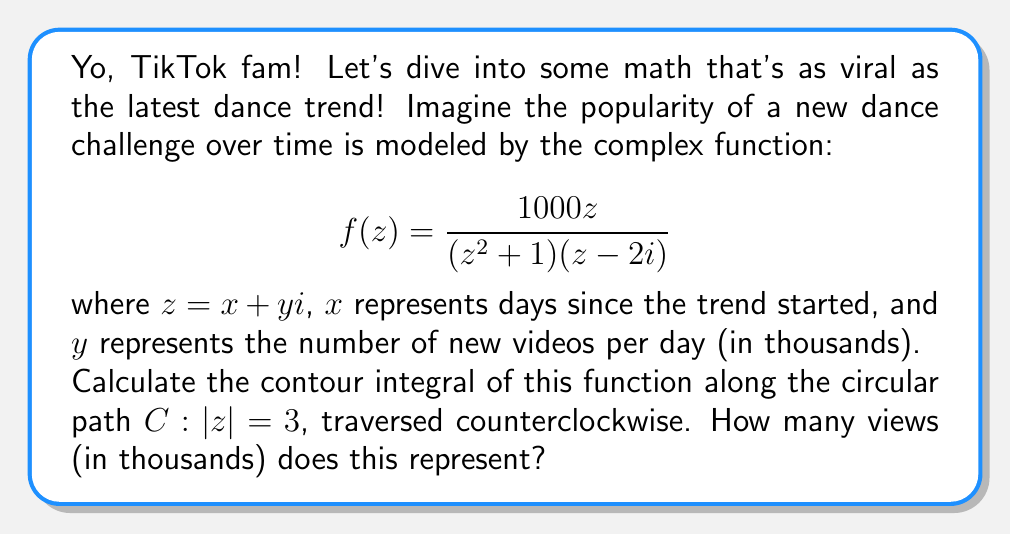Help me with this question. Alright, let's break this down step by step, just like learning a new TikTok dance!

1) First, we need to identify the singularities of the function inside the contour. The poles are:
   - $z = i$ and $z = -i$ from $(z^2 + 1)$
   - $z = 2i$ from $(z - 2i)$

   Only $z = i$ and $z = -i$ are inside our contour $|z| = 3$.

2) Now, we can use the Residue Theorem:

   $$\oint_C f(z) dz = 2\pi i \sum \text{Res}(f, a_k)$$

   where $a_k$ are the poles inside the contour.

3) Let's calculate the residues:

   For $z = i$:
   $$\text{Res}(f, i) = \lim_{z \to i} (z-i)f(z) = \lim_{z \to i} \frac{1000z(z-i)}{(z^2+1)(z-2i)} = \frac{1000i}{2(3i)} = \frac{500}{3}$$

   For $z = -i$:
   $$\text{Res}(f, -i) = \lim_{z \to -i} (z+i)f(z) = \lim_{z \to -i} \frac{1000z(z+i)}{(z^2+1)(z-2i)} = \frac{-1000i}{2(-3i)} = \frac{500}{3}$$

4) Applying the Residue Theorem:

   $$\oint_C f(z) dz = 2\pi i (\frac{500}{3} + \frac{500}{3}) = \frac{2000\pi i}{3}$$

5) The question asks for the magnitude of this result (representing views):

   $$|\frac{2000\pi i}{3}| = \frac{2000\pi}{3} \approx 2094.4$$

Thus, this represents approximately 2094.4 thousand views.
Answer: $\frac{2000\pi}{3}$ thousand views, or approximately 2094.4 thousand views. 